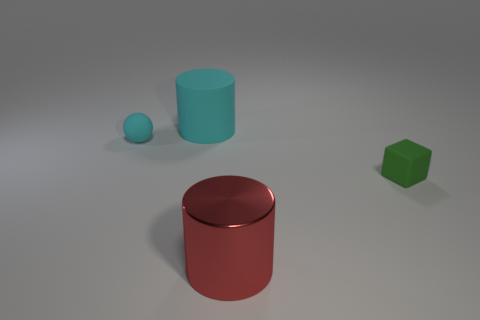Are there any other things that have the same material as the red object?
Give a very brief answer. No. The cube that is the same size as the cyan matte sphere is what color?
Make the answer very short. Green. What material is the big object that is in front of the cube?
Provide a short and direct response. Metal. There is a object that is on the right side of the matte cylinder and left of the tiny green block; what is its material?
Your response must be concise. Metal. Does the cylinder in front of the green object have the same size as the cyan rubber cylinder?
Offer a terse response. Yes. The large red shiny thing is what shape?
Offer a terse response. Cylinder. How many other small rubber objects have the same shape as the green rubber thing?
Ensure brevity in your answer.  0. What number of rubber objects are right of the red cylinder and behind the small rubber ball?
Your answer should be compact. 0. What color is the metallic cylinder?
Offer a terse response. Red. Is there a tiny green object that has the same material as the large red thing?
Your response must be concise. No. 